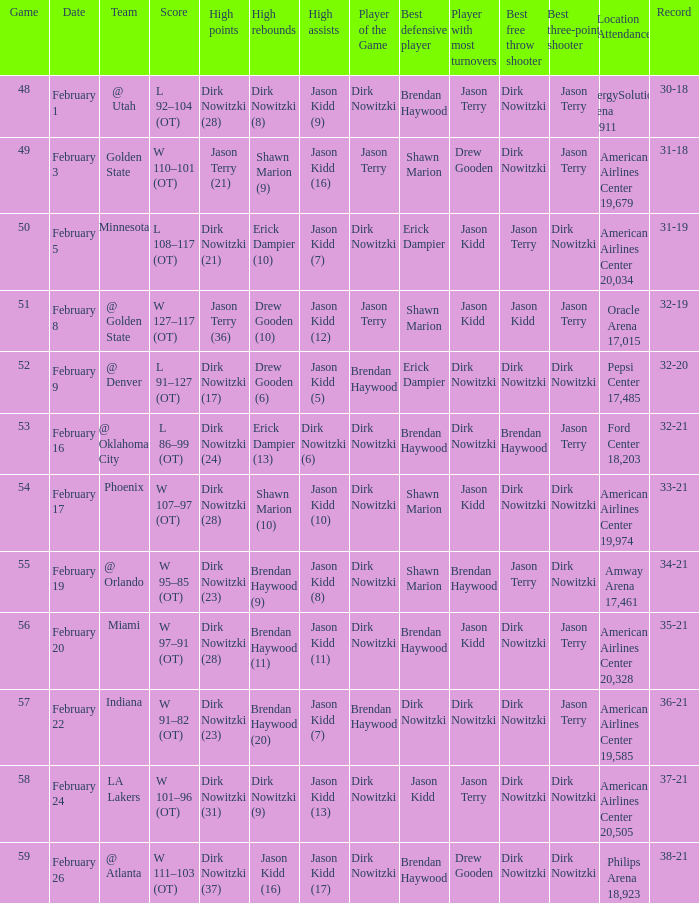When did the Mavericks have a record of 32-19? February 8. 